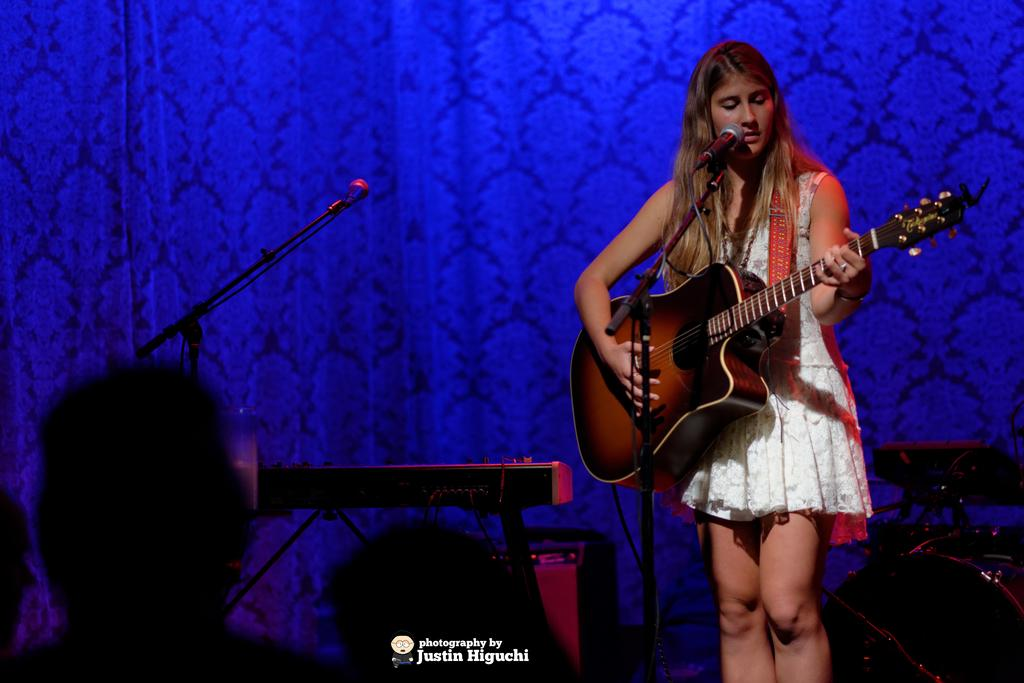Who is the main subject in the image? There is a woman in the image. Where is the woman positioned in the image? The woman is standing on the right side. What is the woman holding in her hand? The woman is holding a guitar in her hand. What activity is the woman engaged in? The woman is singing on a microphone. What other musical instrument can be seen in the image? There is a piano on the left side of the image. Can you see any cactus plants in the background of the image? There is no cactus plant present in the image. 